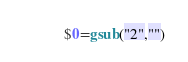Convert code to text. <code><loc_0><loc_0><loc_500><loc_500><_Awk_>$0=gsub("2","")</code> 